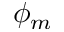<formula> <loc_0><loc_0><loc_500><loc_500>\phi _ { m }</formula> 